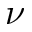<formula> <loc_0><loc_0><loc_500><loc_500>\nu</formula> 